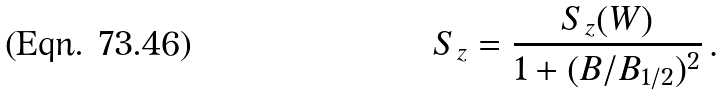<formula> <loc_0><loc_0><loc_500><loc_500>S _ { z } = \frac { S _ { z } ( W ) } { 1 + ( B / B _ { 1 / 2 } ) ^ { 2 } } \, .</formula> 